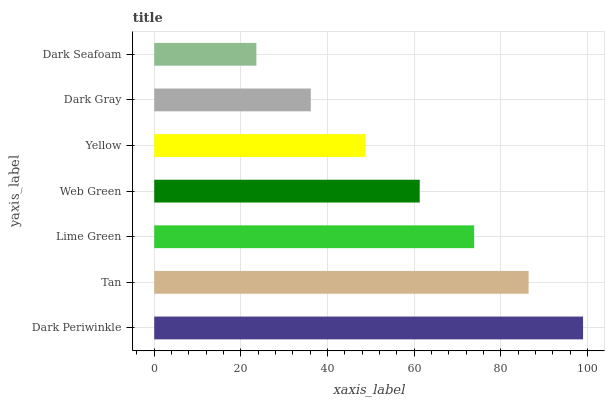Is Dark Seafoam the minimum?
Answer yes or no. Yes. Is Dark Periwinkle the maximum?
Answer yes or no. Yes. Is Tan the minimum?
Answer yes or no. No. Is Tan the maximum?
Answer yes or no. No. Is Dark Periwinkle greater than Tan?
Answer yes or no. Yes. Is Tan less than Dark Periwinkle?
Answer yes or no. Yes. Is Tan greater than Dark Periwinkle?
Answer yes or no. No. Is Dark Periwinkle less than Tan?
Answer yes or no. No. Is Web Green the high median?
Answer yes or no. Yes. Is Web Green the low median?
Answer yes or no. Yes. Is Lime Green the high median?
Answer yes or no. No. Is Lime Green the low median?
Answer yes or no. No. 